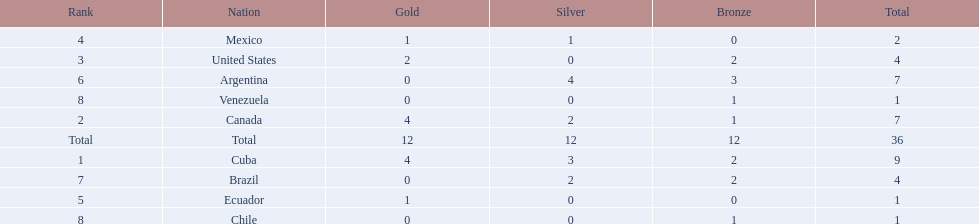Which countries have won gold medals? Cuba, Canada, United States, Mexico, Ecuador. Of these countries, which ones have never won silver or bronze medals? United States, Ecuador. Of the two nations listed previously, which one has only won a gold medal? Ecuador. 